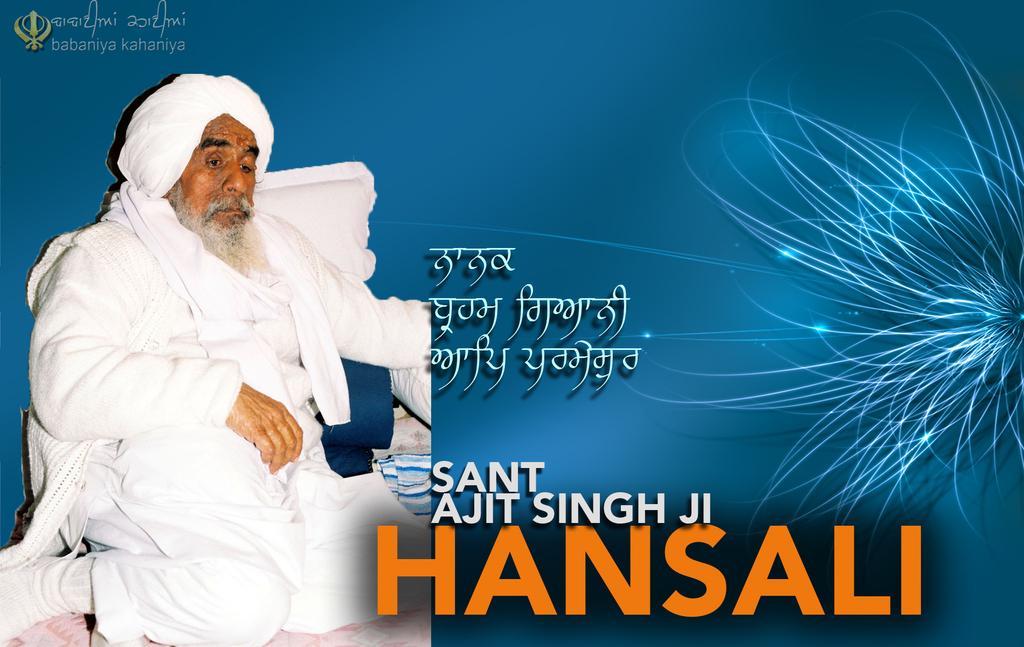Please provide a concise description of this image. This is an advertisement. On the left side of the image we can see a man is sitting on a bed and also we can see pillows, clothes. In the background of the image we can see the text. On the left side of the image we can see a flower. 